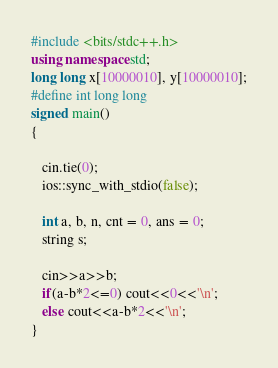<code> <loc_0><loc_0><loc_500><loc_500><_C++_>#include <bits/stdc++.h>
using namespace std;
long long x[10000010], y[10000010];
#define int long long
signed main()
{

   cin.tie(0);
   ios::sync_with_stdio(false);

   int a, b, n, cnt = 0, ans = 0;
   string s;

   cin>>a>>b;
   if(a-b*2<=0) cout<<0<<'\n';
   else cout<<a-b*2<<'\n';
}</code> 